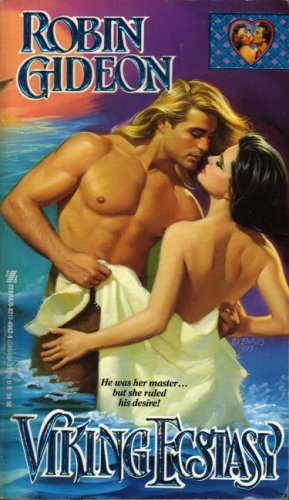What type of book is this? This is a romance novel, as suggested by its evocative cover art depicting a romantic encounter between a man and a woman in a historical setting. 